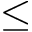<formula> <loc_0><loc_0><loc_500><loc_500>\leq</formula> 